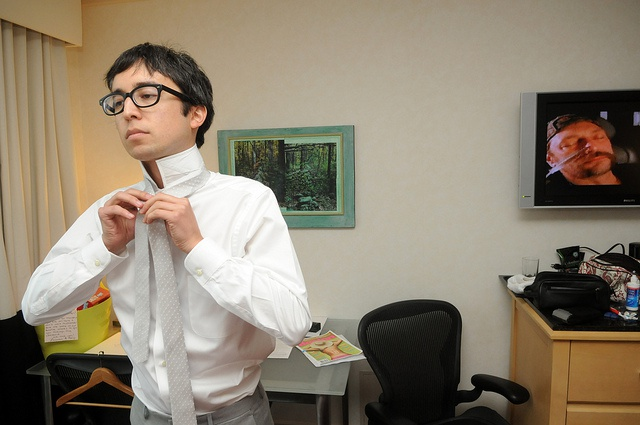Describe the objects in this image and their specific colors. I can see people in olive, lightgray, darkgray, tan, and gray tones, tv in olive, black, maroon, brown, and gray tones, chair in olive, black, and gray tones, tie in olive, darkgray, lightgray, and gray tones, and chair in olive, black, maroon, and brown tones in this image. 